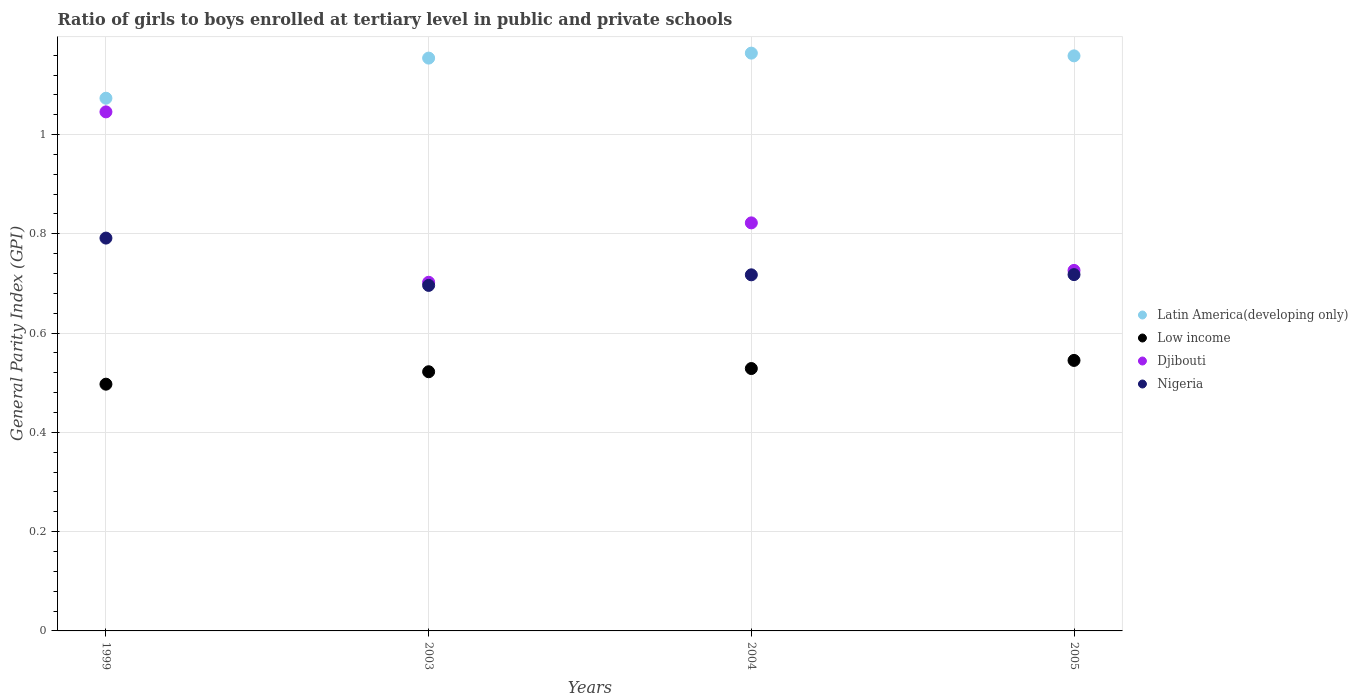What is the general parity index in Low income in 2003?
Offer a very short reply. 0.52. Across all years, what is the maximum general parity index in Latin America(developing only)?
Ensure brevity in your answer.  1.16. Across all years, what is the minimum general parity index in Nigeria?
Provide a short and direct response. 0.7. In which year was the general parity index in Nigeria maximum?
Provide a short and direct response. 1999. In which year was the general parity index in Djibouti minimum?
Keep it short and to the point. 2003. What is the total general parity index in Latin America(developing only) in the graph?
Give a very brief answer. 4.55. What is the difference between the general parity index in Latin America(developing only) in 2004 and that in 2005?
Offer a very short reply. 0.01. What is the difference between the general parity index in Latin America(developing only) in 2003 and the general parity index in Low income in 1999?
Offer a very short reply. 0.66. What is the average general parity index in Low income per year?
Provide a short and direct response. 0.52. In the year 2003, what is the difference between the general parity index in Nigeria and general parity index in Low income?
Keep it short and to the point. 0.17. In how many years, is the general parity index in Low income greater than 0.7600000000000001?
Provide a short and direct response. 0. What is the ratio of the general parity index in Djibouti in 2003 to that in 2005?
Give a very brief answer. 0.97. Is the difference between the general parity index in Nigeria in 1999 and 2003 greater than the difference between the general parity index in Low income in 1999 and 2003?
Your response must be concise. Yes. What is the difference between the highest and the second highest general parity index in Djibouti?
Keep it short and to the point. 0.22. What is the difference between the highest and the lowest general parity index in Nigeria?
Provide a short and direct response. 0.1. Is it the case that in every year, the sum of the general parity index in Nigeria and general parity index in Djibouti  is greater than the sum of general parity index in Low income and general parity index in Latin America(developing only)?
Offer a terse response. Yes. Is it the case that in every year, the sum of the general parity index in Latin America(developing only) and general parity index in Djibouti  is greater than the general parity index in Low income?
Your response must be concise. Yes. Does the general parity index in Low income monotonically increase over the years?
Offer a terse response. Yes. How many years are there in the graph?
Your response must be concise. 4. Are the values on the major ticks of Y-axis written in scientific E-notation?
Your response must be concise. No. Does the graph contain any zero values?
Your response must be concise. No. Does the graph contain grids?
Offer a very short reply. Yes. What is the title of the graph?
Offer a very short reply. Ratio of girls to boys enrolled at tertiary level in public and private schools. What is the label or title of the X-axis?
Your answer should be very brief. Years. What is the label or title of the Y-axis?
Your response must be concise. General Parity Index (GPI). What is the General Parity Index (GPI) in Latin America(developing only) in 1999?
Your answer should be compact. 1.07. What is the General Parity Index (GPI) of Low income in 1999?
Your response must be concise. 0.5. What is the General Parity Index (GPI) in Djibouti in 1999?
Ensure brevity in your answer.  1.05. What is the General Parity Index (GPI) in Nigeria in 1999?
Keep it short and to the point. 0.79. What is the General Parity Index (GPI) in Latin America(developing only) in 2003?
Ensure brevity in your answer.  1.15. What is the General Parity Index (GPI) in Low income in 2003?
Offer a terse response. 0.52. What is the General Parity Index (GPI) in Djibouti in 2003?
Your answer should be very brief. 0.7. What is the General Parity Index (GPI) of Nigeria in 2003?
Offer a very short reply. 0.7. What is the General Parity Index (GPI) in Latin America(developing only) in 2004?
Provide a succinct answer. 1.16. What is the General Parity Index (GPI) in Low income in 2004?
Provide a short and direct response. 0.53. What is the General Parity Index (GPI) of Djibouti in 2004?
Provide a succinct answer. 0.82. What is the General Parity Index (GPI) in Nigeria in 2004?
Your answer should be very brief. 0.72. What is the General Parity Index (GPI) of Latin America(developing only) in 2005?
Keep it short and to the point. 1.16. What is the General Parity Index (GPI) of Low income in 2005?
Your answer should be very brief. 0.55. What is the General Parity Index (GPI) in Djibouti in 2005?
Offer a terse response. 0.73. What is the General Parity Index (GPI) in Nigeria in 2005?
Ensure brevity in your answer.  0.72. Across all years, what is the maximum General Parity Index (GPI) in Latin America(developing only)?
Your answer should be very brief. 1.16. Across all years, what is the maximum General Parity Index (GPI) of Low income?
Offer a very short reply. 0.55. Across all years, what is the maximum General Parity Index (GPI) in Djibouti?
Make the answer very short. 1.05. Across all years, what is the maximum General Parity Index (GPI) in Nigeria?
Your answer should be compact. 0.79. Across all years, what is the minimum General Parity Index (GPI) of Latin America(developing only)?
Keep it short and to the point. 1.07. Across all years, what is the minimum General Parity Index (GPI) in Low income?
Ensure brevity in your answer.  0.5. Across all years, what is the minimum General Parity Index (GPI) of Djibouti?
Provide a succinct answer. 0.7. Across all years, what is the minimum General Parity Index (GPI) of Nigeria?
Offer a terse response. 0.7. What is the total General Parity Index (GPI) of Latin America(developing only) in the graph?
Your answer should be compact. 4.55. What is the total General Parity Index (GPI) of Low income in the graph?
Provide a short and direct response. 2.09. What is the total General Parity Index (GPI) in Djibouti in the graph?
Ensure brevity in your answer.  3.3. What is the total General Parity Index (GPI) in Nigeria in the graph?
Provide a succinct answer. 2.92. What is the difference between the General Parity Index (GPI) in Latin America(developing only) in 1999 and that in 2003?
Provide a succinct answer. -0.08. What is the difference between the General Parity Index (GPI) of Low income in 1999 and that in 2003?
Make the answer very short. -0.03. What is the difference between the General Parity Index (GPI) in Djibouti in 1999 and that in 2003?
Make the answer very short. 0.34. What is the difference between the General Parity Index (GPI) of Nigeria in 1999 and that in 2003?
Provide a succinct answer. 0.1. What is the difference between the General Parity Index (GPI) of Latin America(developing only) in 1999 and that in 2004?
Provide a succinct answer. -0.09. What is the difference between the General Parity Index (GPI) of Low income in 1999 and that in 2004?
Offer a terse response. -0.03. What is the difference between the General Parity Index (GPI) in Djibouti in 1999 and that in 2004?
Make the answer very short. 0.22. What is the difference between the General Parity Index (GPI) of Nigeria in 1999 and that in 2004?
Provide a short and direct response. 0.07. What is the difference between the General Parity Index (GPI) in Latin America(developing only) in 1999 and that in 2005?
Your answer should be compact. -0.09. What is the difference between the General Parity Index (GPI) in Low income in 1999 and that in 2005?
Offer a very short reply. -0.05. What is the difference between the General Parity Index (GPI) of Djibouti in 1999 and that in 2005?
Ensure brevity in your answer.  0.32. What is the difference between the General Parity Index (GPI) in Nigeria in 1999 and that in 2005?
Give a very brief answer. 0.07. What is the difference between the General Parity Index (GPI) in Latin America(developing only) in 2003 and that in 2004?
Give a very brief answer. -0.01. What is the difference between the General Parity Index (GPI) in Low income in 2003 and that in 2004?
Make the answer very short. -0.01. What is the difference between the General Parity Index (GPI) in Djibouti in 2003 and that in 2004?
Keep it short and to the point. -0.12. What is the difference between the General Parity Index (GPI) in Nigeria in 2003 and that in 2004?
Provide a short and direct response. -0.02. What is the difference between the General Parity Index (GPI) of Latin America(developing only) in 2003 and that in 2005?
Offer a very short reply. -0. What is the difference between the General Parity Index (GPI) in Low income in 2003 and that in 2005?
Make the answer very short. -0.02. What is the difference between the General Parity Index (GPI) in Djibouti in 2003 and that in 2005?
Give a very brief answer. -0.02. What is the difference between the General Parity Index (GPI) in Nigeria in 2003 and that in 2005?
Offer a very short reply. -0.02. What is the difference between the General Parity Index (GPI) of Latin America(developing only) in 2004 and that in 2005?
Make the answer very short. 0.01. What is the difference between the General Parity Index (GPI) of Low income in 2004 and that in 2005?
Your answer should be very brief. -0.02. What is the difference between the General Parity Index (GPI) of Djibouti in 2004 and that in 2005?
Make the answer very short. 0.1. What is the difference between the General Parity Index (GPI) in Nigeria in 2004 and that in 2005?
Your answer should be very brief. -0. What is the difference between the General Parity Index (GPI) in Latin America(developing only) in 1999 and the General Parity Index (GPI) in Low income in 2003?
Keep it short and to the point. 0.55. What is the difference between the General Parity Index (GPI) in Latin America(developing only) in 1999 and the General Parity Index (GPI) in Djibouti in 2003?
Your answer should be compact. 0.37. What is the difference between the General Parity Index (GPI) in Latin America(developing only) in 1999 and the General Parity Index (GPI) in Nigeria in 2003?
Your response must be concise. 0.38. What is the difference between the General Parity Index (GPI) in Low income in 1999 and the General Parity Index (GPI) in Djibouti in 2003?
Keep it short and to the point. -0.21. What is the difference between the General Parity Index (GPI) in Low income in 1999 and the General Parity Index (GPI) in Nigeria in 2003?
Give a very brief answer. -0.2. What is the difference between the General Parity Index (GPI) of Djibouti in 1999 and the General Parity Index (GPI) of Nigeria in 2003?
Your response must be concise. 0.35. What is the difference between the General Parity Index (GPI) of Latin America(developing only) in 1999 and the General Parity Index (GPI) of Low income in 2004?
Your answer should be compact. 0.54. What is the difference between the General Parity Index (GPI) in Latin America(developing only) in 1999 and the General Parity Index (GPI) in Djibouti in 2004?
Your answer should be very brief. 0.25. What is the difference between the General Parity Index (GPI) of Latin America(developing only) in 1999 and the General Parity Index (GPI) of Nigeria in 2004?
Ensure brevity in your answer.  0.36. What is the difference between the General Parity Index (GPI) in Low income in 1999 and the General Parity Index (GPI) in Djibouti in 2004?
Make the answer very short. -0.33. What is the difference between the General Parity Index (GPI) of Low income in 1999 and the General Parity Index (GPI) of Nigeria in 2004?
Ensure brevity in your answer.  -0.22. What is the difference between the General Parity Index (GPI) in Djibouti in 1999 and the General Parity Index (GPI) in Nigeria in 2004?
Offer a terse response. 0.33. What is the difference between the General Parity Index (GPI) of Latin America(developing only) in 1999 and the General Parity Index (GPI) of Low income in 2005?
Make the answer very short. 0.53. What is the difference between the General Parity Index (GPI) of Latin America(developing only) in 1999 and the General Parity Index (GPI) of Djibouti in 2005?
Your answer should be very brief. 0.35. What is the difference between the General Parity Index (GPI) in Latin America(developing only) in 1999 and the General Parity Index (GPI) in Nigeria in 2005?
Your response must be concise. 0.36. What is the difference between the General Parity Index (GPI) of Low income in 1999 and the General Parity Index (GPI) of Djibouti in 2005?
Keep it short and to the point. -0.23. What is the difference between the General Parity Index (GPI) of Low income in 1999 and the General Parity Index (GPI) of Nigeria in 2005?
Make the answer very short. -0.22. What is the difference between the General Parity Index (GPI) of Djibouti in 1999 and the General Parity Index (GPI) of Nigeria in 2005?
Offer a very short reply. 0.33. What is the difference between the General Parity Index (GPI) of Latin America(developing only) in 2003 and the General Parity Index (GPI) of Low income in 2004?
Ensure brevity in your answer.  0.63. What is the difference between the General Parity Index (GPI) of Latin America(developing only) in 2003 and the General Parity Index (GPI) of Djibouti in 2004?
Offer a very short reply. 0.33. What is the difference between the General Parity Index (GPI) in Latin America(developing only) in 2003 and the General Parity Index (GPI) in Nigeria in 2004?
Make the answer very short. 0.44. What is the difference between the General Parity Index (GPI) in Low income in 2003 and the General Parity Index (GPI) in Djibouti in 2004?
Your response must be concise. -0.3. What is the difference between the General Parity Index (GPI) of Low income in 2003 and the General Parity Index (GPI) of Nigeria in 2004?
Offer a terse response. -0.2. What is the difference between the General Parity Index (GPI) of Djibouti in 2003 and the General Parity Index (GPI) of Nigeria in 2004?
Give a very brief answer. -0.01. What is the difference between the General Parity Index (GPI) of Latin America(developing only) in 2003 and the General Parity Index (GPI) of Low income in 2005?
Ensure brevity in your answer.  0.61. What is the difference between the General Parity Index (GPI) in Latin America(developing only) in 2003 and the General Parity Index (GPI) in Djibouti in 2005?
Provide a short and direct response. 0.43. What is the difference between the General Parity Index (GPI) of Latin America(developing only) in 2003 and the General Parity Index (GPI) of Nigeria in 2005?
Keep it short and to the point. 0.44. What is the difference between the General Parity Index (GPI) in Low income in 2003 and the General Parity Index (GPI) in Djibouti in 2005?
Provide a short and direct response. -0.2. What is the difference between the General Parity Index (GPI) of Low income in 2003 and the General Parity Index (GPI) of Nigeria in 2005?
Offer a very short reply. -0.2. What is the difference between the General Parity Index (GPI) of Djibouti in 2003 and the General Parity Index (GPI) of Nigeria in 2005?
Make the answer very short. -0.02. What is the difference between the General Parity Index (GPI) in Latin America(developing only) in 2004 and the General Parity Index (GPI) in Low income in 2005?
Provide a short and direct response. 0.62. What is the difference between the General Parity Index (GPI) in Latin America(developing only) in 2004 and the General Parity Index (GPI) in Djibouti in 2005?
Offer a very short reply. 0.44. What is the difference between the General Parity Index (GPI) of Latin America(developing only) in 2004 and the General Parity Index (GPI) of Nigeria in 2005?
Give a very brief answer. 0.45. What is the difference between the General Parity Index (GPI) of Low income in 2004 and the General Parity Index (GPI) of Djibouti in 2005?
Ensure brevity in your answer.  -0.2. What is the difference between the General Parity Index (GPI) of Low income in 2004 and the General Parity Index (GPI) of Nigeria in 2005?
Your answer should be compact. -0.19. What is the difference between the General Parity Index (GPI) of Djibouti in 2004 and the General Parity Index (GPI) of Nigeria in 2005?
Provide a succinct answer. 0.1. What is the average General Parity Index (GPI) in Latin America(developing only) per year?
Provide a short and direct response. 1.14. What is the average General Parity Index (GPI) of Low income per year?
Provide a short and direct response. 0.52. What is the average General Parity Index (GPI) in Djibouti per year?
Offer a very short reply. 0.82. What is the average General Parity Index (GPI) of Nigeria per year?
Your answer should be very brief. 0.73. In the year 1999, what is the difference between the General Parity Index (GPI) in Latin America(developing only) and General Parity Index (GPI) in Low income?
Make the answer very short. 0.58. In the year 1999, what is the difference between the General Parity Index (GPI) of Latin America(developing only) and General Parity Index (GPI) of Djibouti?
Keep it short and to the point. 0.03. In the year 1999, what is the difference between the General Parity Index (GPI) in Latin America(developing only) and General Parity Index (GPI) in Nigeria?
Keep it short and to the point. 0.28. In the year 1999, what is the difference between the General Parity Index (GPI) of Low income and General Parity Index (GPI) of Djibouti?
Make the answer very short. -0.55. In the year 1999, what is the difference between the General Parity Index (GPI) of Low income and General Parity Index (GPI) of Nigeria?
Your answer should be compact. -0.29. In the year 1999, what is the difference between the General Parity Index (GPI) of Djibouti and General Parity Index (GPI) of Nigeria?
Ensure brevity in your answer.  0.25. In the year 2003, what is the difference between the General Parity Index (GPI) in Latin America(developing only) and General Parity Index (GPI) in Low income?
Ensure brevity in your answer.  0.63. In the year 2003, what is the difference between the General Parity Index (GPI) in Latin America(developing only) and General Parity Index (GPI) in Djibouti?
Provide a short and direct response. 0.45. In the year 2003, what is the difference between the General Parity Index (GPI) of Latin America(developing only) and General Parity Index (GPI) of Nigeria?
Provide a succinct answer. 0.46. In the year 2003, what is the difference between the General Parity Index (GPI) of Low income and General Parity Index (GPI) of Djibouti?
Your answer should be compact. -0.18. In the year 2003, what is the difference between the General Parity Index (GPI) of Low income and General Parity Index (GPI) of Nigeria?
Your answer should be very brief. -0.17. In the year 2003, what is the difference between the General Parity Index (GPI) of Djibouti and General Parity Index (GPI) of Nigeria?
Make the answer very short. 0.01. In the year 2004, what is the difference between the General Parity Index (GPI) in Latin America(developing only) and General Parity Index (GPI) in Low income?
Your answer should be compact. 0.64. In the year 2004, what is the difference between the General Parity Index (GPI) of Latin America(developing only) and General Parity Index (GPI) of Djibouti?
Offer a terse response. 0.34. In the year 2004, what is the difference between the General Parity Index (GPI) of Latin America(developing only) and General Parity Index (GPI) of Nigeria?
Offer a very short reply. 0.45. In the year 2004, what is the difference between the General Parity Index (GPI) in Low income and General Parity Index (GPI) in Djibouti?
Your answer should be very brief. -0.29. In the year 2004, what is the difference between the General Parity Index (GPI) in Low income and General Parity Index (GPI) in Nigeria?
Keep it short and to the point. -0.19. In the year 2004, what is the difference between the General Parity Index (GPI) in Djibouti and General Parity Index (GPI) in Nigeria?
Ensure brevity in your answer.  0.1. In the year 2005, what is the difference between the General Parity Index (GPI) of Latin America(developing only) and General Parity Index (GPI) of Low income?
Your answer should be compact. 0.61. In the year 2005, what is the difference between the General Parity Index (GPI) of Latin America(developing only) and General Parity Index (GPI) of Djibouti?
Provide a succinct answer. 0.43. In the year 2005, what is the difference between the General Parity Index (GPI) in Latin America(developing only) and General Parity Index (GPI) in Nigeria?
Provide a short and direct response. 0.44. In the year 2005, what is the difference between the General Parity Index (GPI) in Low income and General Parity Index (GPI) in Djibouti?
Make the answer very short. -0.18. In the year 2005, what is the difference between the General Parity Index (GPI) of Low income and General Parity Index (GPI) of Nigeria?
Ensure brevity in your answer.  -0.17. In the year 2005, what is the difference between the General Parity Index (GPI) in Djibouti and General Parity Index (GPI) in Nigeria?
Your response must be concise. 0.01. What is the ratio of the General Parity Index (GPI) of Latin America(developing only) in 1999 to that in 2003?
Give a very brief answer. 0.93. What is the ratio of the General Parity Index (GPI) in Djibouti in 1999 to that in 2003?
Give a very brief answer. 1.49. What is the ratio of the General Parity Index (GPI) of Nigeria in 1999 to that in 2003?
Offer a terse response. 1.14. What is the ratio of the General Parity Index (GPI) in Latin America(developing only) in 1999 to that in 2004?
Provide a short and direct response. 0.92. What is the ratio of the General Parity Index (GPI) of Low income in 1999 to that in 2004?
Your answer should be very brief. 0.94. What is the ratio of the General Parity Index (GPI) in Djibouti in 1999 to that in 2004?
Give a very brief answer. 1.27. What is the ratio of the General Parity Index (GPI) in Nigeria in 1999 to that in 2004?
Ensure brevity in your answer.  1.1. What is the ratio of the General Parity Index (GPI) of Latin America(developing only) in 1999 to that in 2005?
Ensure brevity in your answer.  0.93. What is the ratio of the General Parity Index (GPI) in Low income in 1999 to that in 2005?
Keep it short and to the point. 0.91. What is the ratio of the General Parity Index (GPI) in Djibouti in 1999 to that in 2005?
Your answer should be very brief. 1.44. What is the ratio of the General Parity Index (GPI) in Nigeria in 1999 to that in 2005?
Ensure brevity in your answer.  1.1. What is the ratio of the General Parity Index (GPI) of Djibouti in 2003 to that in 2004?
Give a very brief answer. 0.85. What is the ratio of the General Parity Index (GPI) of Nigeria in 2003 to that in 2004?
Keep it short and to the point. 0.97. What is the ratio of the General Parity Index (GPI) of Latin America(developing only) in 2003 to that in 2005?
Make the answer very short. 1. What is the ratio of the General Parity Index (GPI) in Low income in 2003 to that in 2005?
Make the answer very short. 0.96. What is the ratio of the General Parity Index (GPI) of Djibouti in 2003 to that in 2005?
Provide a short and direct response. 0.97. What is the ratio of the General Parity Index (GPI) in Nigeria in 2003 to that in 2005?
Offer a terse response. 0.97. What is the ratio of the General Parity Index (GPI) in Low income in 2004 to that in 2005?
Make the answer very short. 0.97. What is the ratio of the General Parity Index (GPI) in Djibouti in 2004 to that in 2005?
Ensure brevity in your answer.  1.13. What is the difference between the highest and the second highest General Parity Index (GPI) of Latin America(developing only)?
Your response must be concise. 0.01. What is the difference between the highest and the second highest General Parity Index (GPI) of Low income?
Provide a succinct answer. 0.02. What is the difference between the highest and the second highest General Parity Index (GPI) in Djibouti?
Give a very brief answer. 0.22. What is the difference between the highest and the second highest General Parity Index (GPI) in Nigeria?
Offer a terse response. 0.07. What is the difference between the highest and the lowest General Parity Index (GPI) in Latin America(developing only)?
Your answer should be very brief. 0.09. What is the difference between the highest and the lowest General Parity Index (GPI) of Low income?
Provide a short and direct response. 0.05. What is the difference between the highest and the lowest General Parity Index (GPI) of Djibouti?
Provide a succinct answer. 0.34. What is the difference between the highest and the lowest General Parity Index (GPI) in Nigeria?
Give a very brief answer. 0.1. 